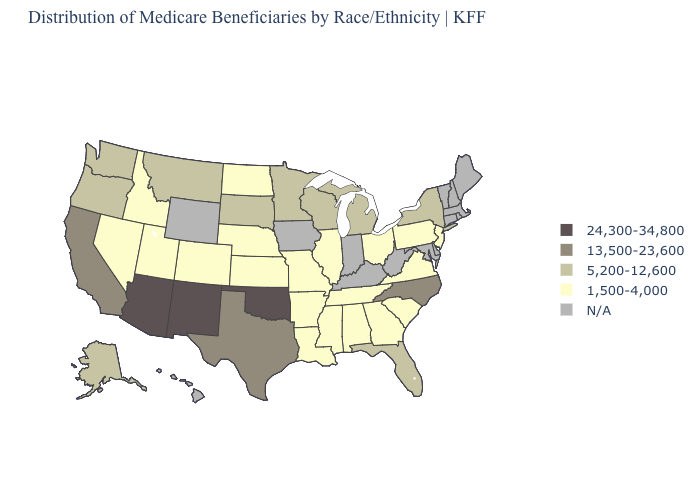Does Mississippi have the highest value in the USA?
Concise answer only. No. What is the value of North Carolina?
Quick response, please. 13,500-23,600. Name the states that have a value in the range 24,300-34,800?
Concise answer only. Arizona, New Mexico, Oklahoma. Which states have the highest value in the USA?
Be succinct. Arizona, New Mexico, Oklahoma. Does New York have the highest value in the Northeast?
Concise answer only. Yes. Name the states that have a value in the range 5,200-12,600?
Be succinct. Alaska, Florida, Michigan, Minnesota, Montana, New York, Oregon, South Dakota, Washington, Wisconsin. Name the states that have a value in the range N/A?
Be succinct. Connecticut, Delaware, Hawaii, Indiana, Iowa, Kentucky, Maine, Maryland, Massachusetts, New Hampshire, Rhode Island, Vermont, West Virginia, Wyoming. Name the states that have a value in the range 5,200-12,600?
Quick response, please. Alaska, Florida, Michigan, Minnesota, Montana, New York, Oregon, South Dakota, Washington, Wisconsin. Name the states that have a value in the range 13,500-23,600?
Give a very brief answer. California, North Carolina, Texas. Which states have the lowest value in the USA?
Short answer required. Alabama, Arkansas, Colorado, Georgia, Idaho, Illinois, Kansas, Louisiana, Mississippi, Missouri, Nebraska, Nevada, New Jersey, North Dakota, Ohio, Pennsylvania, South Carolina, Tennessee, Utah, Virginia. What is the highest value in the South ?
Quick response, please. 24,300-34,800. What is the highest value in states that border Illinois?
Keep it brief. 5,200-12,600. Among the states that border Oregon , which have the lowest value?
Concise answer only. Idaho, Nevada. 